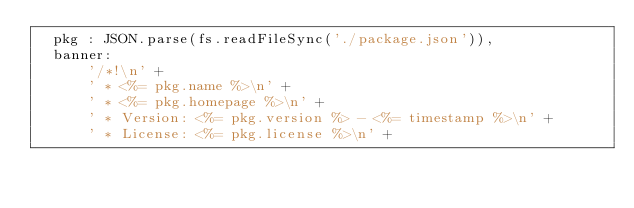Convert code to text. <code><loc_0><loc_0><loc_500><loc_500><_JavaScript_>  pkg : JSON.parse(fs.readFileSync('./package.json')),
  banner:
      '/*!\n' +
      ' * <%= pkg.name %>\n' +
      ' * <%= pkg.homepage %>\n' +
      ' * Version: <%= pkg.version %> - <%= timestamp %>\n' +
      ' * License: <%= pkg.license %>\n' +</code> 